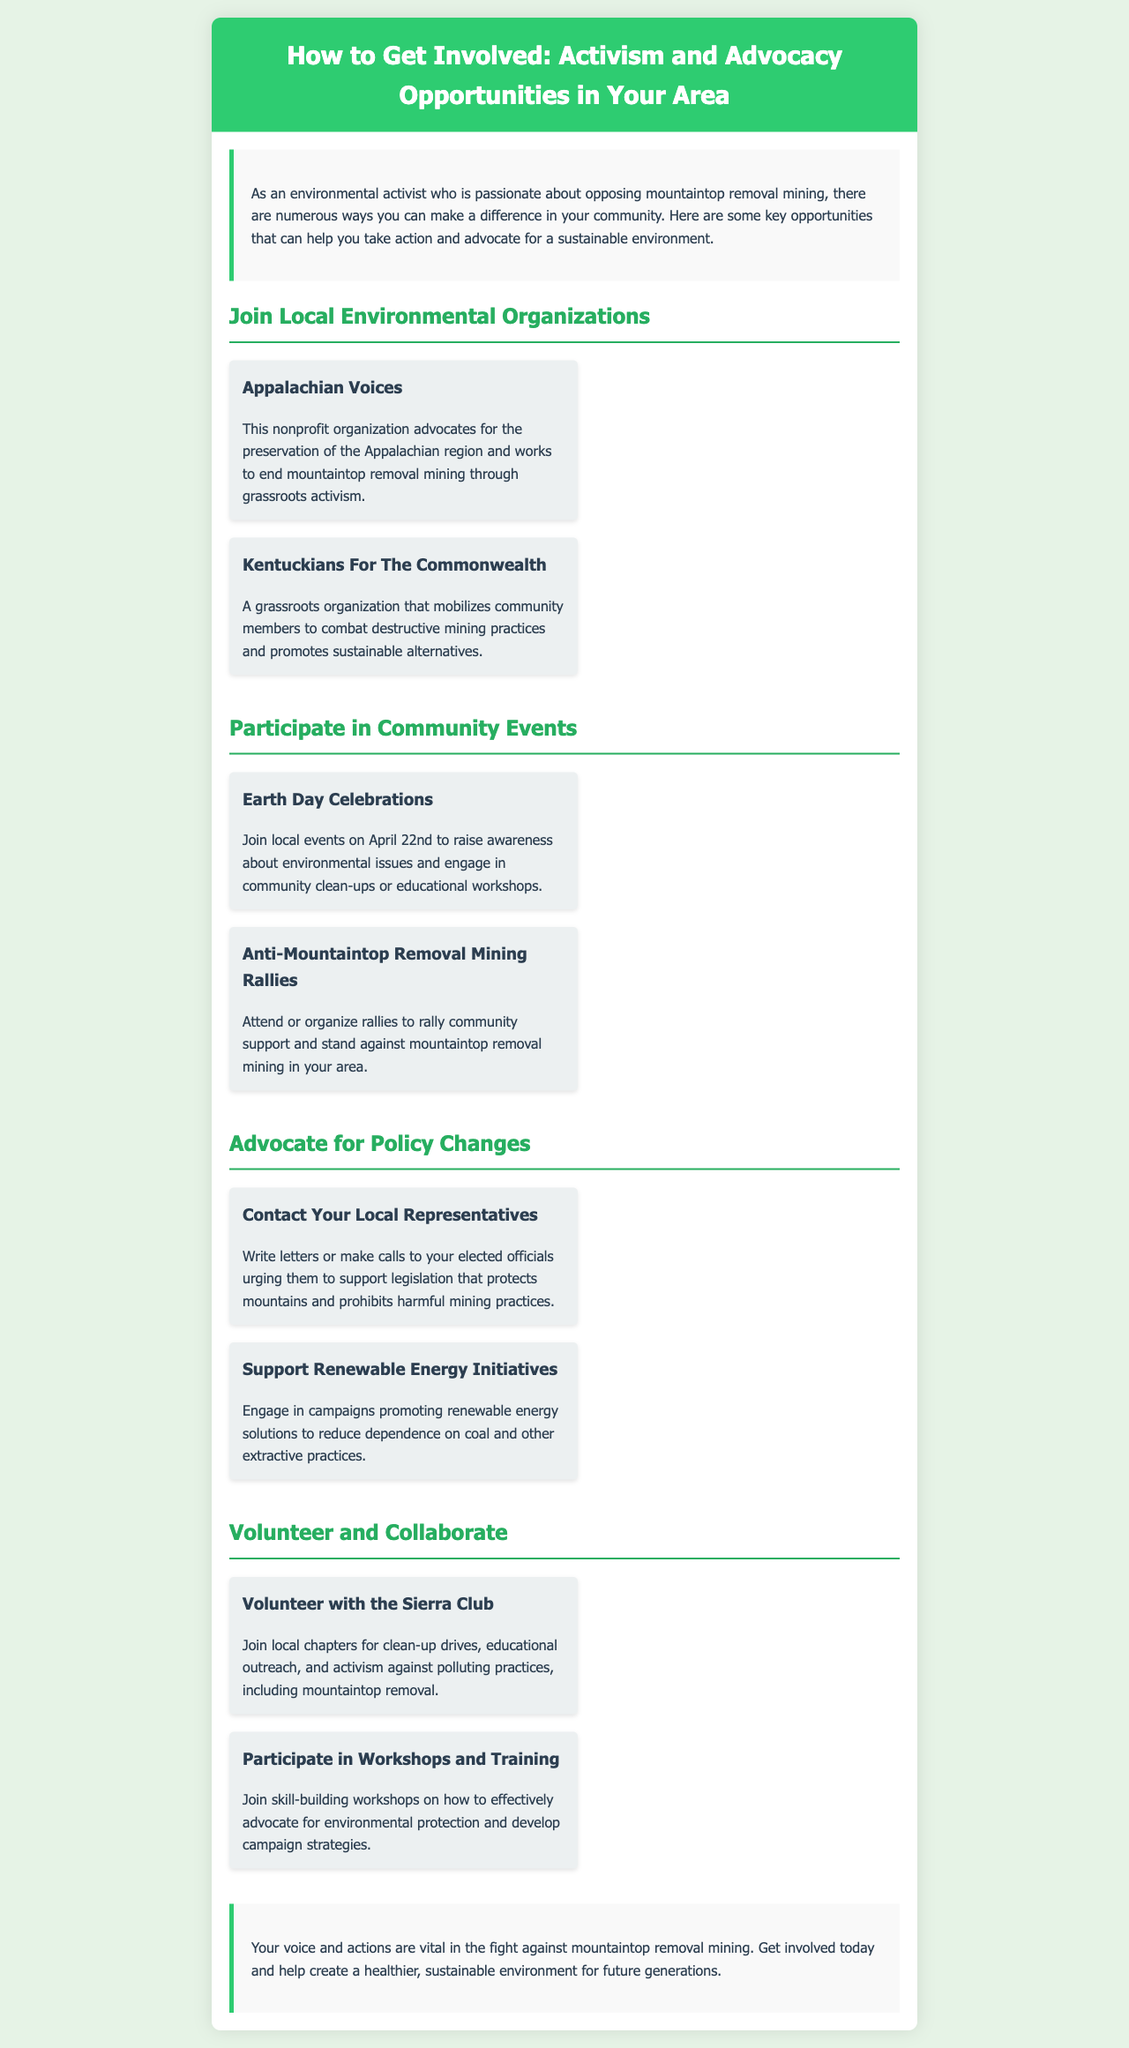What is the main focus of the brochure? The brochure focuses on activism and advocacy opportunities for environmental issues, specifically opposing mountaintop removal mining.
Answer: Activism and advocacy opportunities Which organization advocates for the preservation of the Appalachian region? The document states that Appalachian Voices is a nonprofit organization advocating for the preservation of the Appalachian region.
Answer: Appalachian Voices What is the date for Earth Day celebrations mentioned? The document specifies that Earth Day Celebrations occur on April 22nd each year.
Answer: April 22nd Name one way to advocate for policy changes. The document lists contacting local representatives as a way to advocate for policy changes.
Answer: Contact Your Local Representatives What type of event can you attend to support anti-mountaintop removal efforts? The document mentions attending rallies as an opportunity to support anti-mountaintop removal efforts.
Answer: Anti-Mountaintop Removal Mining Rallies Which organization allows volunteering for clean-up drives and activism? The Sierra Club is mentioned as an organization where you can volunteer for clean-up drives and activism against polluting practices.
Answer: Sierra Club What kind of workshops can you participate in according to the brochure? The document notes that you can participate in skill-building workshops on effective advocacy for environmental protection.
Answer: Skill-building workshops How many local environmental organizations are mentioned? There are four local environmental organizations listed in the document.
Answer: Four What two actions are suggested for participating in community events? Attending Earth Day Celebrations and organizing rallies are suggested actions in the document.
Answer: Earth Day Celebrations and rallies 